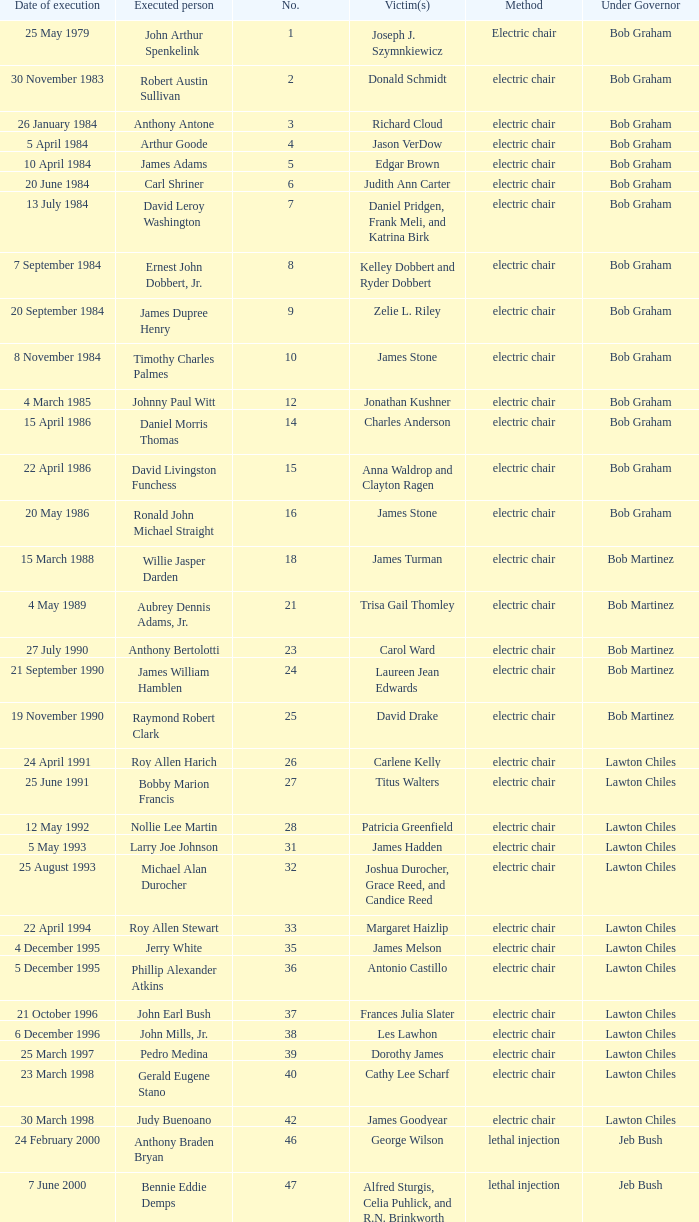What's the name of Linroy Bottoson's victim? Catherine Alexander. 